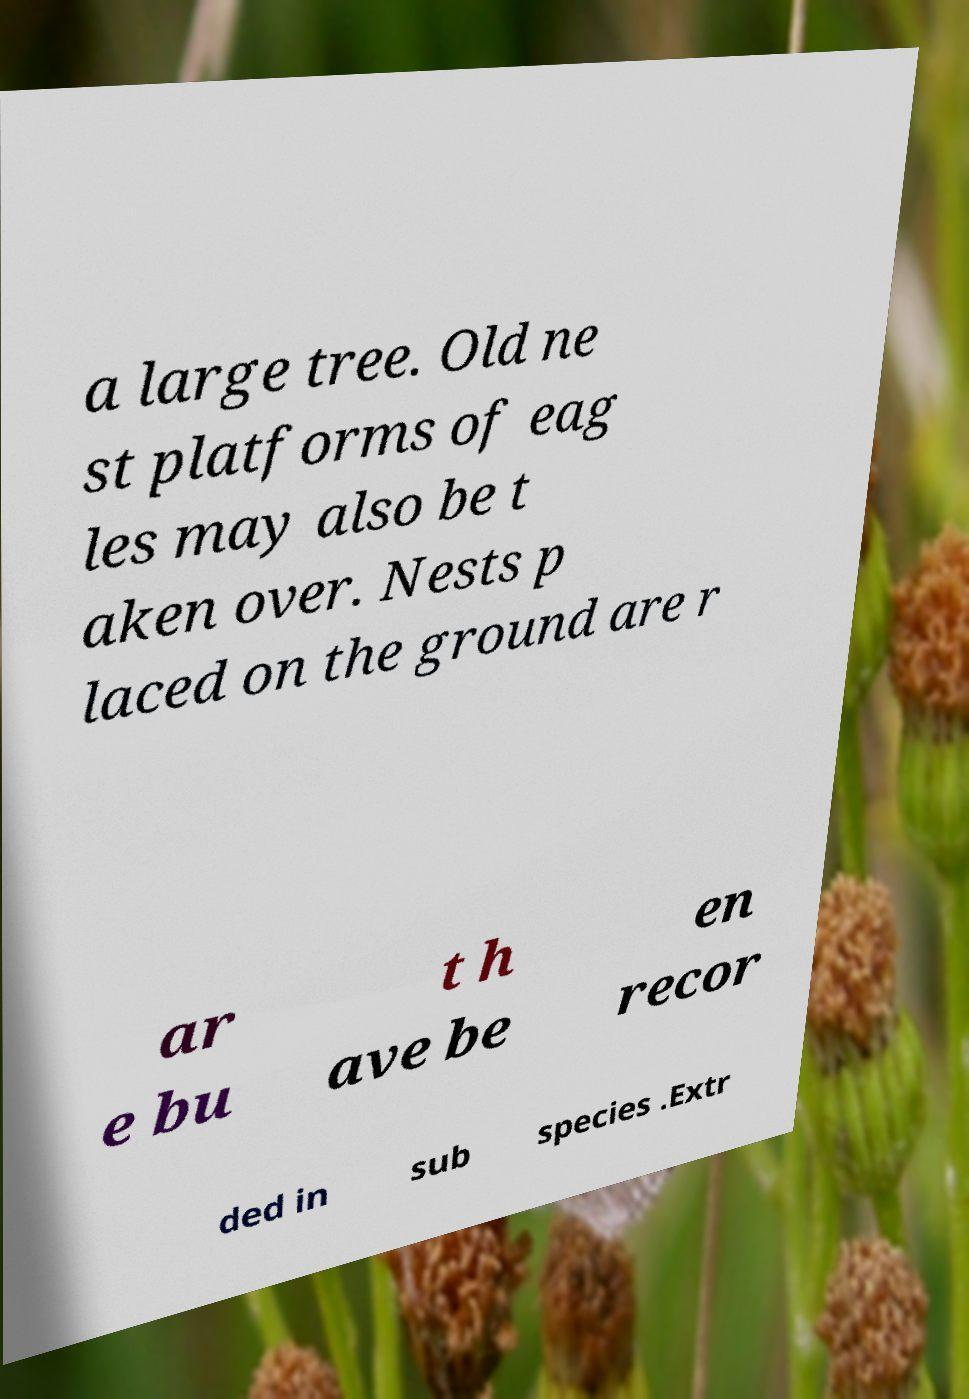Could you assist in decoding the text presented in this image and type it out clearly? a large tree. Old ne st platforms of eag les may also be t aken over. Nests p laced on the ground are r ar e bu t h ave be en recor ded in sub species .Extr 